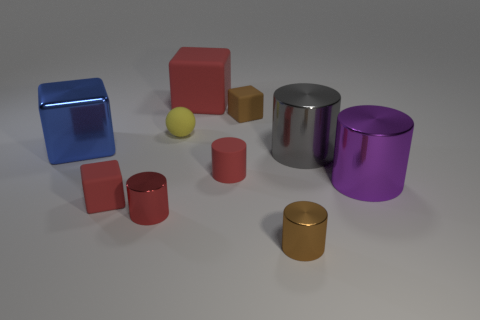Can you describe the colors and textures present in the image? Certainly, the image displays a collection of objects with a matte finish in various colors including blue, red, yellow, purple, and gold. Some items have a reflective metallic texture, whereas the rubber cube looks matte and non-reflective. 